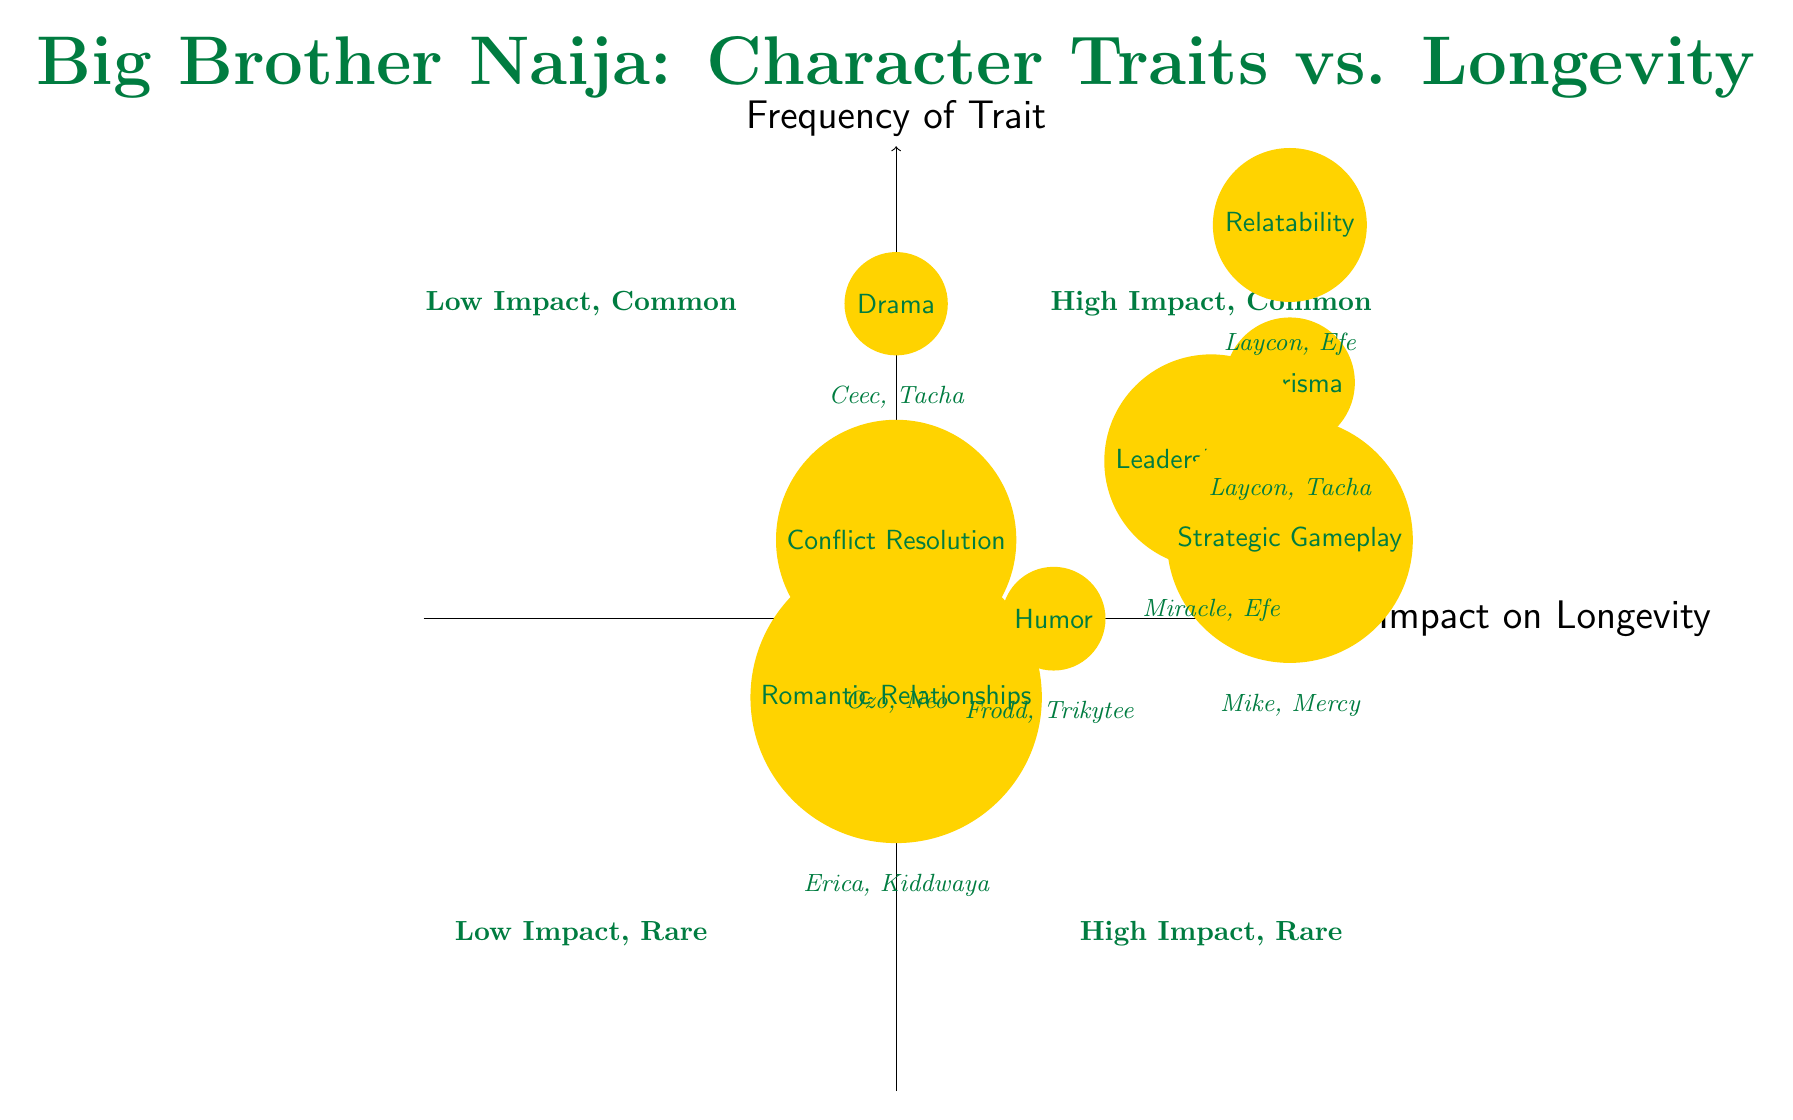What character trait has the highest impact on longevity? In the diagram, 'Charisma' is situated in the quadrant for high impact, indicating it has the highest impact on longevity.
Answer: Charisma Which contestant is associated with the trait of 'Conflict Resolution'? Looking at the examples listed under 'Conflict Resolution,' the contestant associated with that trait is 'Ozo' and 'Neo.' Therefore, either can be correct.
Answer: Ozo (or Neo) How many traits show a high impact on longevity? The diagram displays four traits in the high impact area: 'Charisma,' 'Leadership Skills,' 'Relatability,' and 'Strategic Gameplay.' Thus, there are four traits that show a high impact.
Answer: 4 What is the impact on longevity for the trait of 'Humor'? The diagram indicates that 'Humor' is placed in the medium impact area of the chart, suggesting its effect on longevity is neither high nor low but rather average.
Answer: Medium Which trait has mixed impact on longevity? The traits labeled with mixed impact are 'Drama' and 'Romantic Relationships,' both situated in the mixed impact area of the diagram, indicating variations in effect on longevity.
Answer: Drama (or Romantic Relationships) Which trait appears in the 'High Impact, Rare' quadrant? By examining the diagram, the trait 'Romantic Relationships' is located in the quadrant labeled 'High Impact, Rare,' suggesting that it can contribute significantly to longevity, although it is less frequently observed among contestants.
Answer: Romantic Relationships How many character traits are classified under low impact on longevity? There are no character traits visually displayed in the low impact areas of the quadrant chart; thus, this indicates that there are zero character traits classified under low impact.
Answer: 0 Which contestant is linked with the 'Leadership Skills' trait? The trait 'Leadership Skills' in the diagram is associated with the contestants 'Miracle' and 'Efe,' either of whom can be a correct example related to that character trait.
Answer: Miracle (or Efe) 